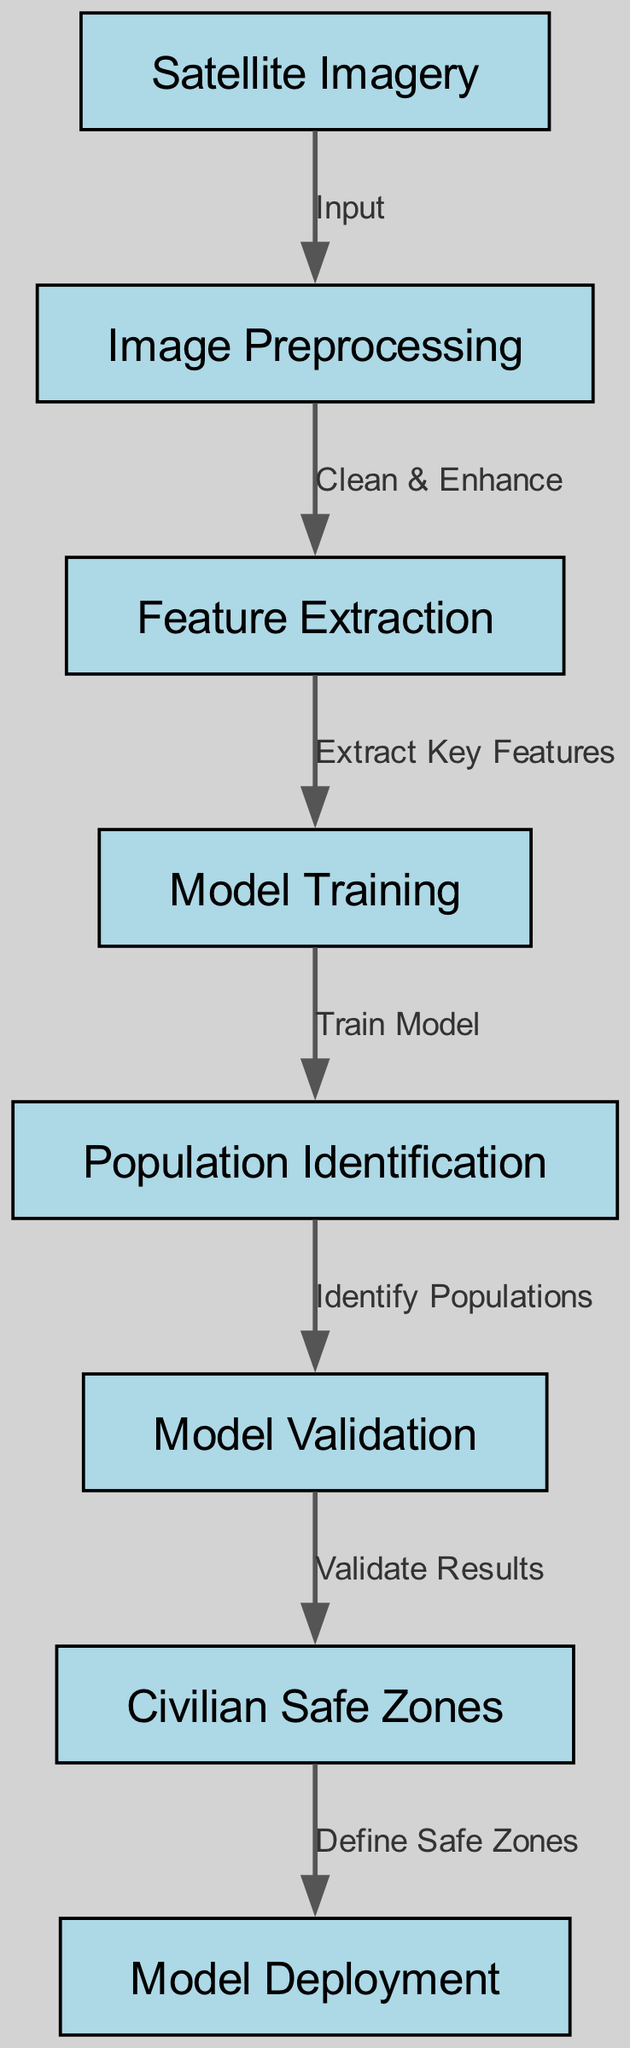What is the first node in the diagram? The first node is "Satellite Imagery," which is the initial source input for the process. This can be determined by tracing the flow from the start of the diagram where inputs are introduced.
Answer: Satellite Imagery How many nodes are there in total? There are a total of eight nodes listed in the diagram, including both inputs and outputs. This is found by counting each unique labeled node present in the diagram.
Answer: Eight What does the edge between "Model Training" and "Population Identification" represent? The edge between these two nodes is labeled "Train Model," indicating that the model training process directly feeds into the population identification step. This shows the sequential relationship where the model utilizes training to identify populations.
Answer: Train Model Which node comes after "Validation"? The node that follows "Validation" is "Civilian Safe Zones," indicating that the validation results lead to the identification of areas deemed safe for civilians. This can be observed by following the directed flow in the diagram.
Answer: Civilian Safe Zones What is the purpose of the "Feature Extraction" node? The "Feature Extraction" node serves the purpose of extracting key features from the satellite imagery after preprocessing has occurred. This step is critical as it identifies the important aspects needed for model training.
Answer: Extract Key Features What is the last stage in the process shown in the diagram? The last stage in the process is "Model Deployment," where the validated identities or locations identified as civilian safe zones can be deployed for real-world application. This is determined by following the flow from start to finish in the diagram.
Answer: Model Deployment What is the relationship between "Preprocessing" and "Feature Extraction"? The relationship is signified by the label "Clean & Enhance," indicating that preprocessing is aimed at preparing the image data so that important features can be effectively extracted afterward. This is shown by tracing the directional edge from preprocessing to feature extraction.
Answer: Clean & Enhance What is indicated by the label on the edge from "Validation" to "Civilian Safe Zones"? The label "Validate Results" indicates that the purpose of this edge is to confirm the results obtained from the population identification process, ensuring that determined civilian zones are accurate and reliable. This conclusion follows from the stepwise connections of nodes and labeling of edges.
Answer: Validate Results 